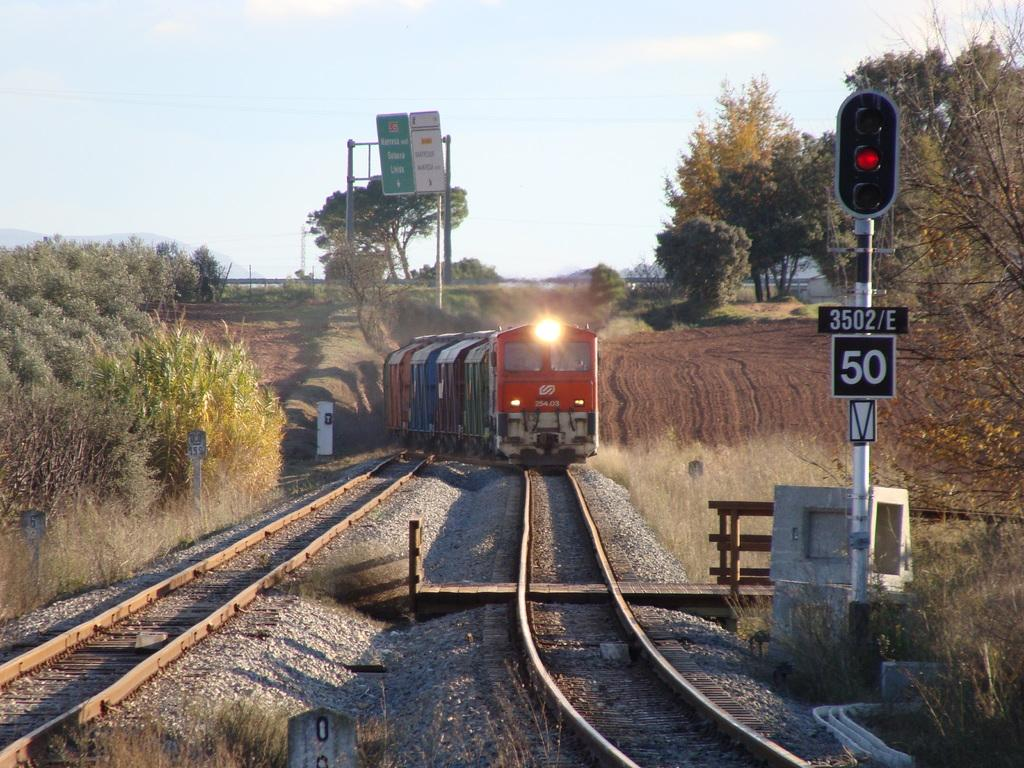What is the main subject of the image? The main subject of the image is a train on the railway track. What safety feature can be seen in the image? There are signal lights in the image. What type of structures are present in the image? There are boards attached to poles in the image. What type of vegetation is visible in the image? There is grass, plants, and trees visible in the image. What part of the natural environment is visible in the image? The sky is visible in the image. What type of cork can be seen floating in the image? There is no cork present in the image; it features a train on a railway track with signal lights, boards, vegetation, and the sky. 